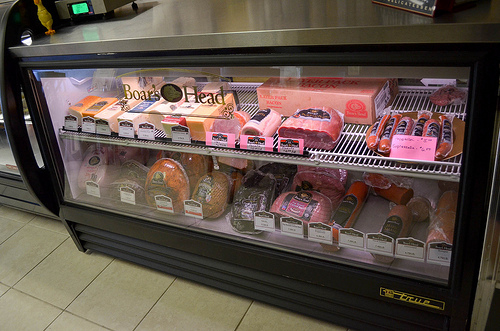<image>
Is there a floor under the table? No. The floor is not positioned under the table. The vertical relationship between these objects is different. 